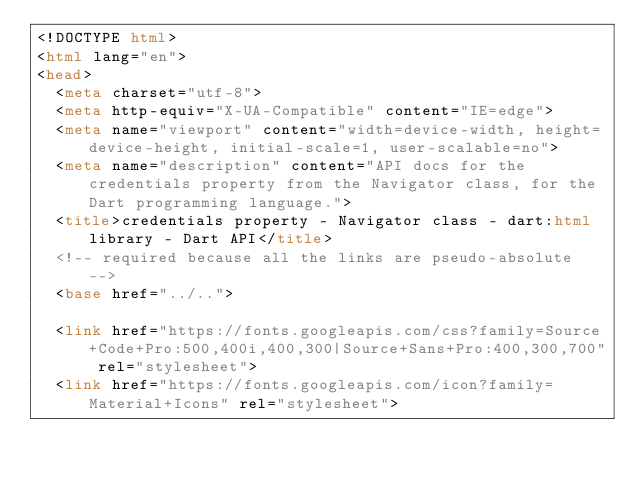<code> <loc_0><loc_0><loc_500><loc_500><_HTML_><!DOCTYPE html>
<html lang="en">
<head>
  <meta charset="utf-8">
  <meta http-equiv="X-UA-Compatible" content="IE=edge">
  <meta name="viewport" content="width=device-width, height=device-height, initial-scale=1, user-scalable=no">
  <meta name="description" content="API docs for the credentials property from the Navigator class, for the Dart programming language.">
  <title>credentials property - Navigator class - dart:html library - Dart API</title>
  <!-- required because all the links are pseudo-absolute -->
  <base href="../..">

  <link href="https://fonts.googleapis.com/css?family=Source+Code+Pro:500,400i,400,300|Source+Sans+Pro:400,300,700" rel="stylesheet">
  <link href="https://fonts.googleapis.com/icon?family=Material+Icons" rel="stylesheet"></code> 